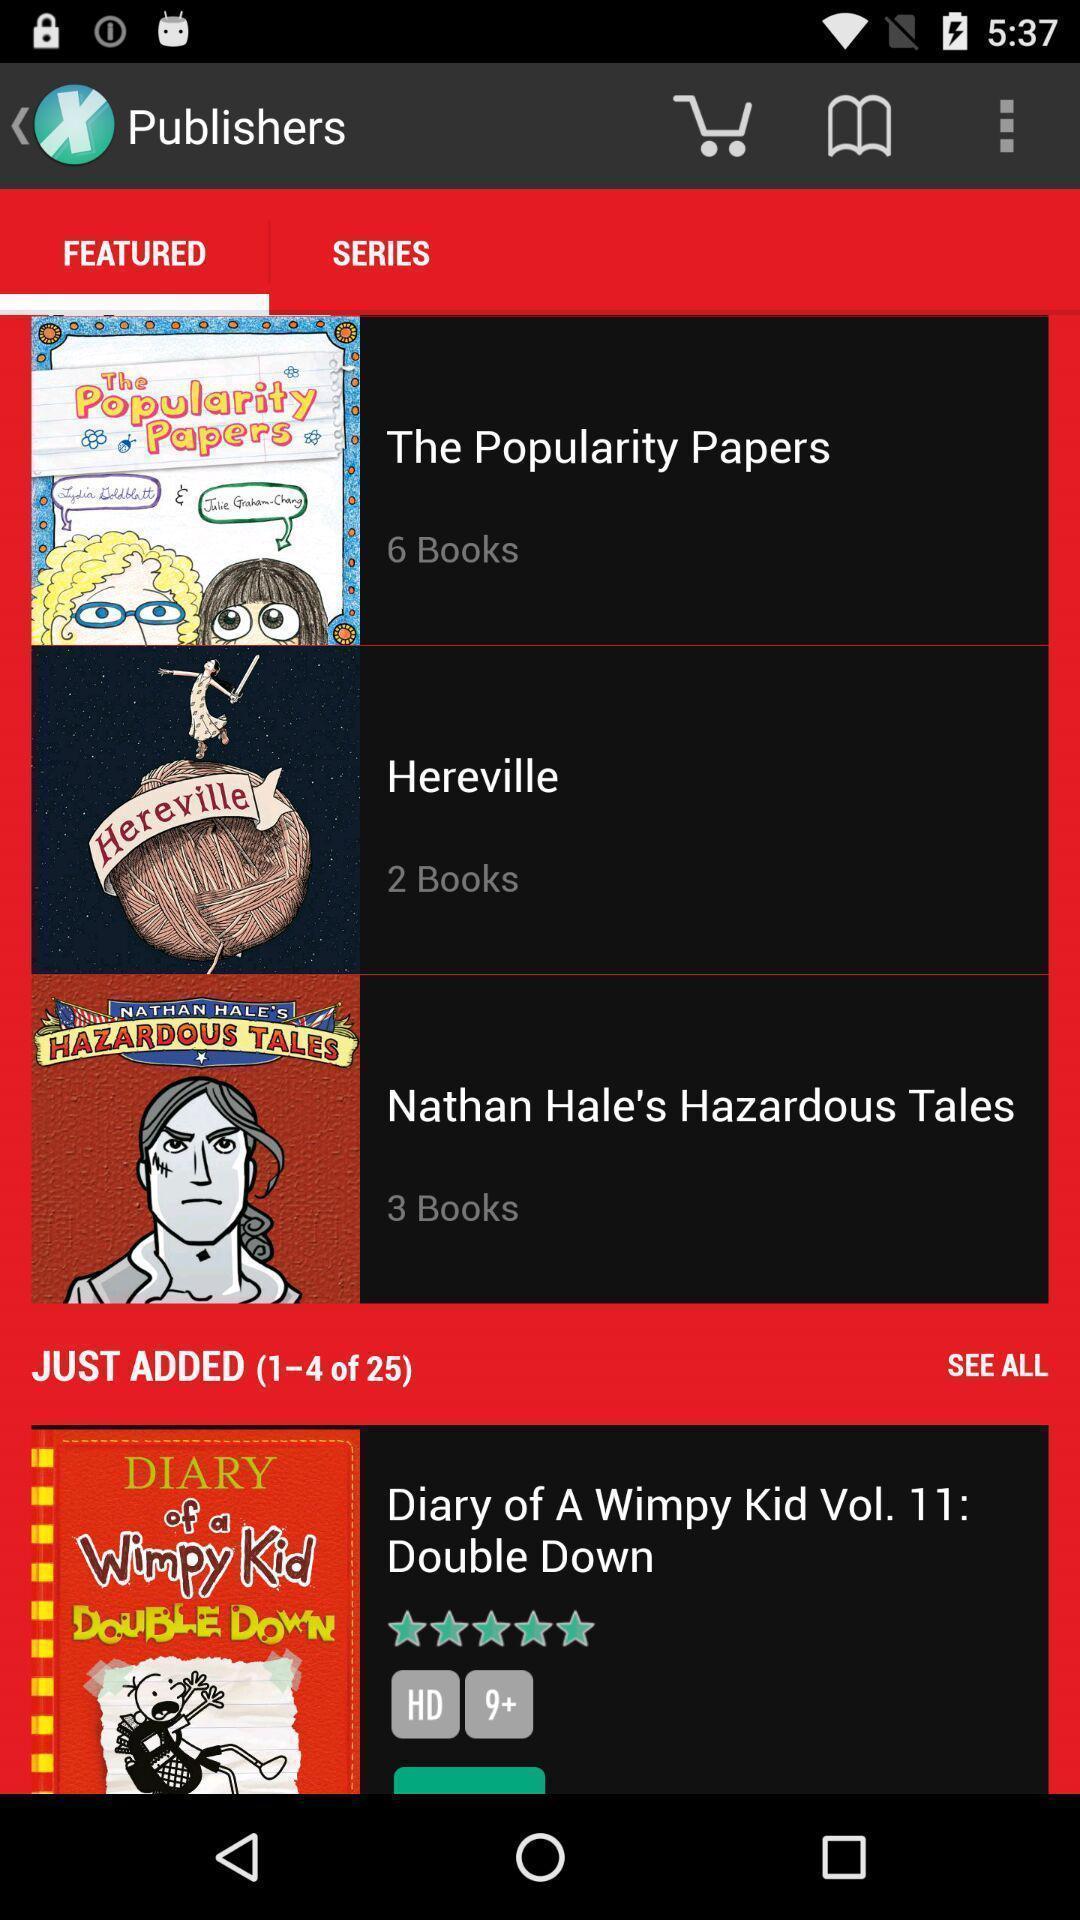What details can you identify in this image? Screen shows list of features in a shopping app. 